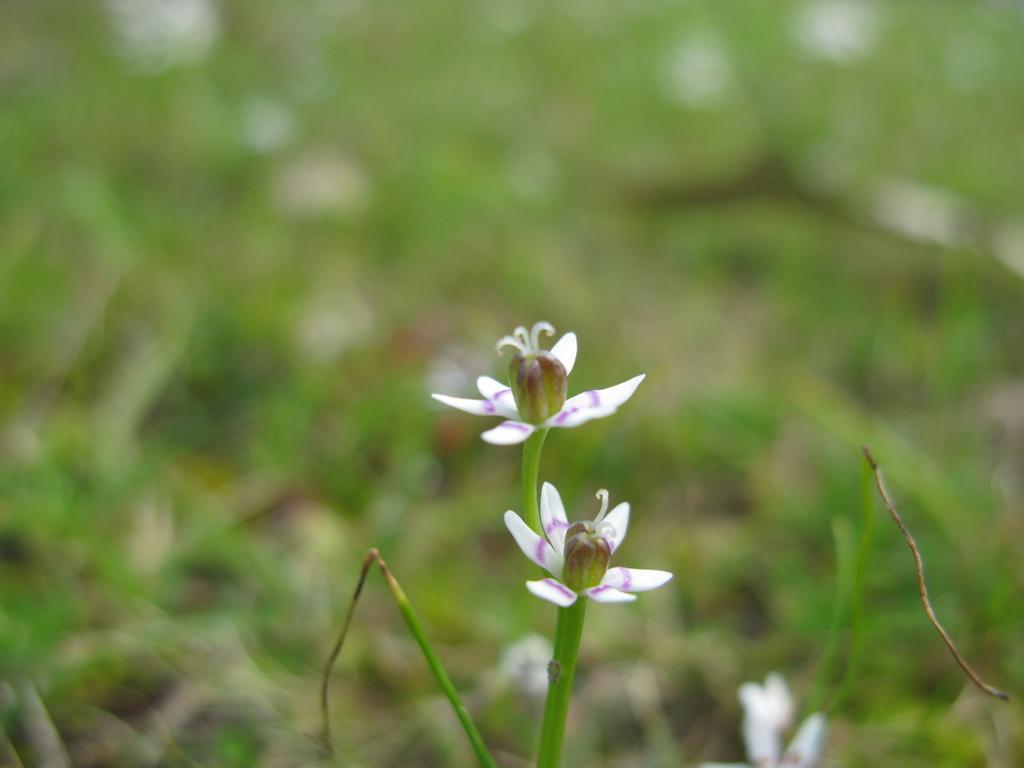How would you summarize this image in a sentence or two? In the foreground of the picture there are flowers and stems. The background is blurred. In the background there is greenery. 